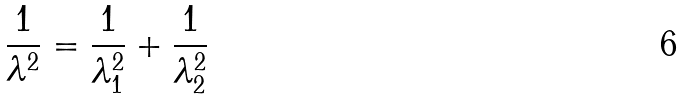Convert formula to latex. <formula><loc_0><loc_0><loc_500><loc_500>\frac { 1 } { \lambda ^ { 2 } } = \frac { 1 } { \lambda _ { 1 } ^ { 2 } } + \frac { 1 } { \lambda _ { 2 } ^ { 2 } }</formula> 